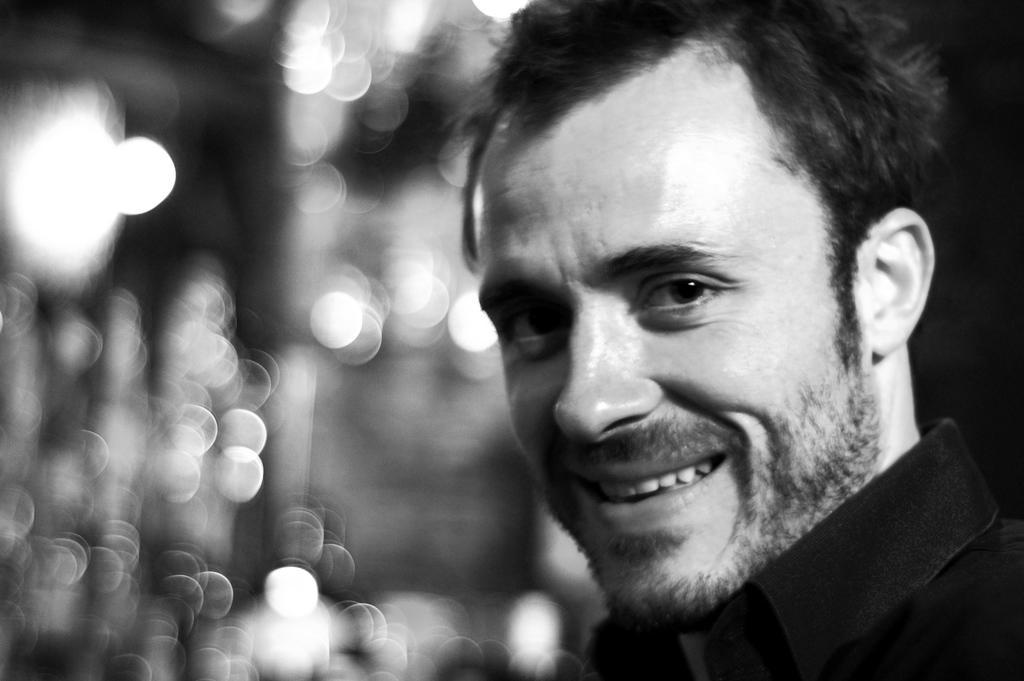Describe this image in one or two sentences. This image is black and white. In this image there is a person with smile. 